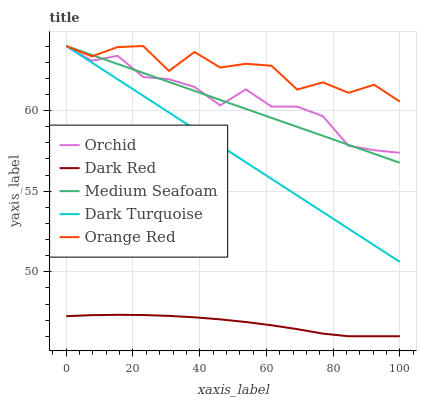Does Dark Red have the minimum area under the curve?
Answer yes or no. Yes. Does Orange Red have the maximum area under the curve?
Answer yes or no. Yes. Does Medium Seafoam have the minimum area under the curve?
Answer yes or no. No. Does Medium Seafoam have the maximum area under the curve?
Answer yes or no. No. Is Medium Seafoam the smoothest?
Answer yes or no. Yes. Is Orange Red the roughest?
Answer yes or no. Yes. Is Orange Red the smoothest?
Answer yes or no. No. Is Medium Seafoam the roughest?
Answer yes or no. No. Does Dark Red have the lowest value?
Answer yes or no. Yes. Does Medium Seafoam have the lowest value?
Answer yes or no. No. Does Orchid have the highest value?
Answer yes or no. Yes. Is Dark Red less than Orchid?
Answer yes or no. Yes. Is Dark Turquoise greater than Dark Red?
Answer yes or no. Yes. Does Orchid intersect Orange Red?
Answer yes or no. Yes. Is Orchid less than Orange Red?
Answer yes or no. No. Is Orchid greater than Orange Red?
Answer yes or no. No. Does Dark Red intersect Orchid?
Answer yes or no. No. 